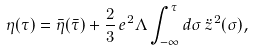Convert formula to latex. <formula><loc_0><loc_0><loc_500><loc_500>\eta ( \tau ) = { \bar { \eta } } ( { \bar { \tau } } ) + \frac { 2 } { 3 } \, e ^ { 2 } \Lambda \int _ { - \infty } ^ { \tau } d \sigma \, { \ddot { z } } ^ { 2 } ( \sigma ) ,</formula> 